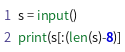Convert code to text. <code><loc_0><loc_0><loc_500><loc_500><_Python_>s = input()
print(s[:(len(s)-8)]</code> 